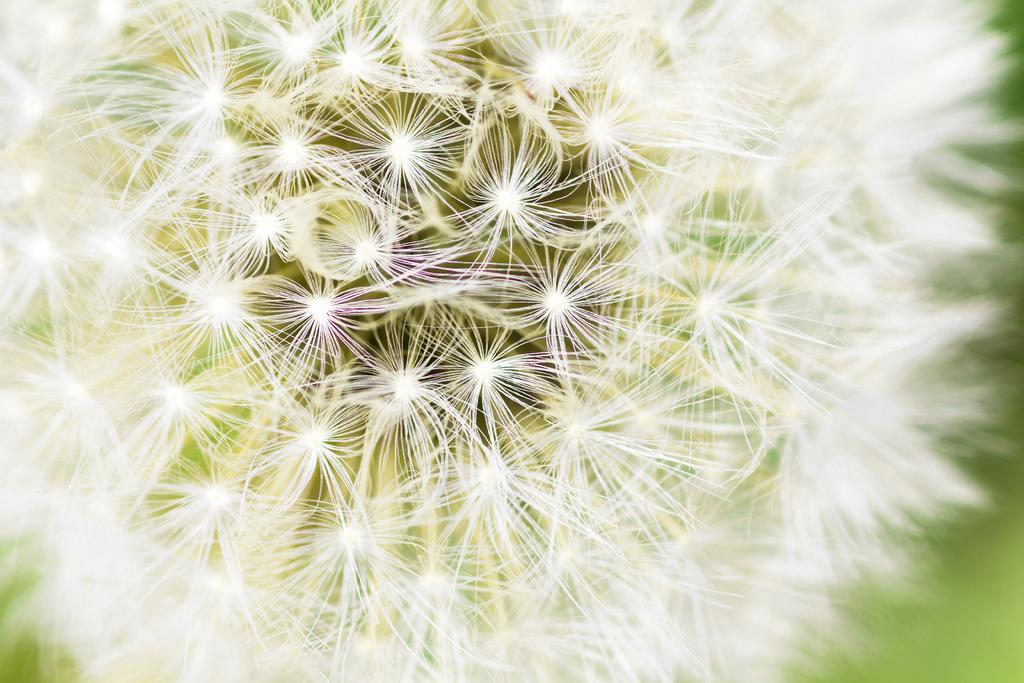What type of flower is in the image? There is a dandelion flower in the image. What is the color of the dandelion flower? The dandelion flower is white in color. What type of string is attached to the curtain in the image? There is no string or curtain present in the image; it only features a dandelion flower. How many balls are visible in the image? There are no balls present in the image; it only features a dandelion flower. 